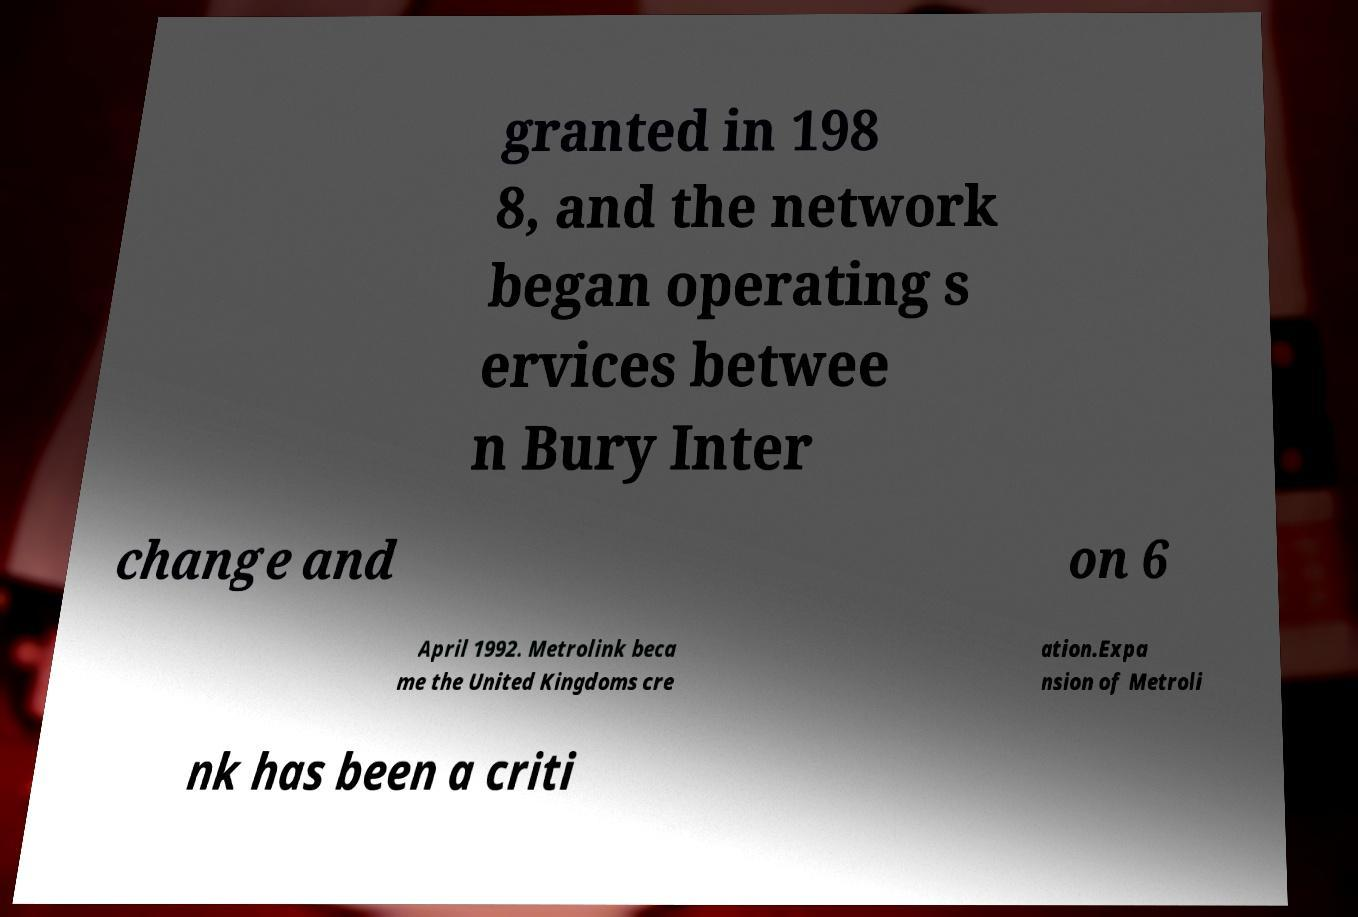Can you read and provide the text displayed in the image?This photo seems to have some interesting text. Can you extract and type it out for me? granted in 198 8, and the network began operating s ervices betwee n Bury Inter change and on 6 April 1992. Metrolink beca me the United Kingdoms cre ation.Expa nsion of Metroli nk has been a criti 